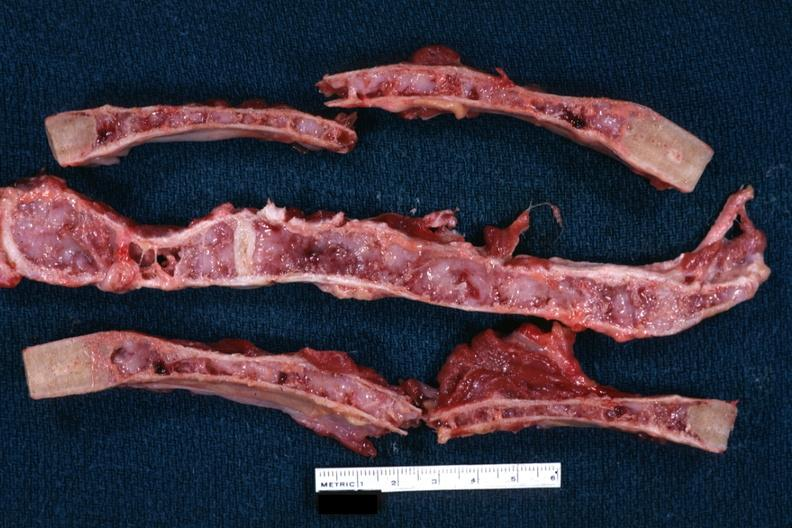what is present?
Answer the question using a single word or phrase. Thorax 